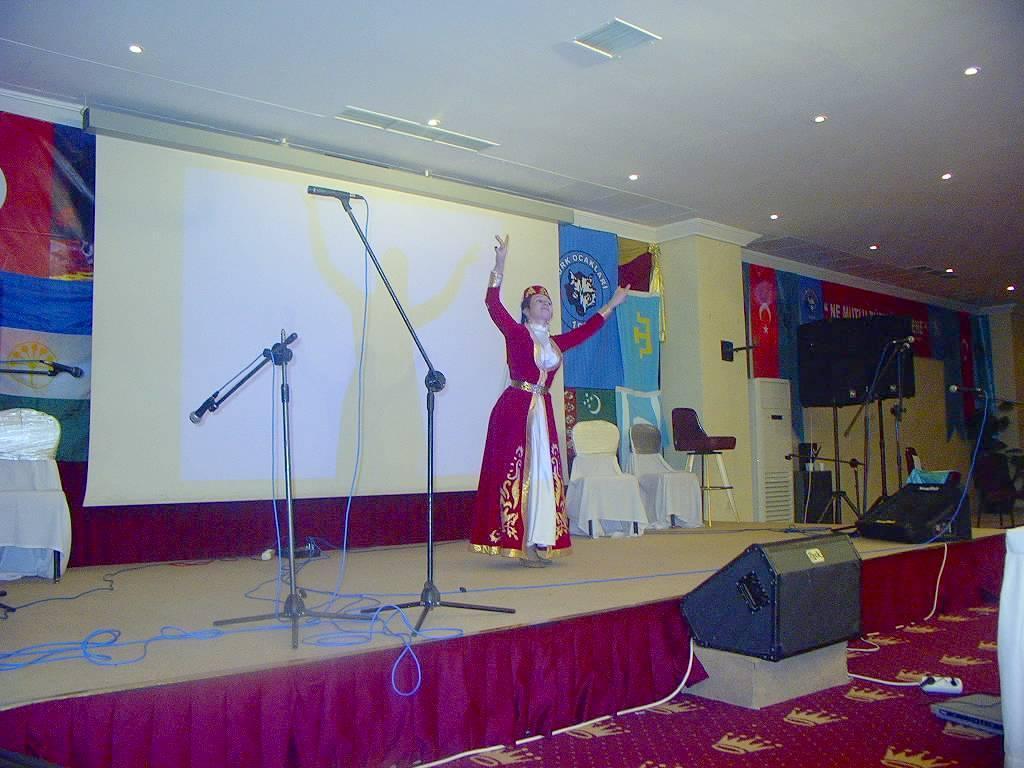Describe this image in one or two sentences. In this picture we can see a woman wearing a costume. There are a few microphones, wires, chairs, loudspeakers and other objects on the stage. We can see a projector screen and a few colorful posters from left to right. There is a switchboard, loudspeaker and a carpet on the ground. Some lights are visible on top. 